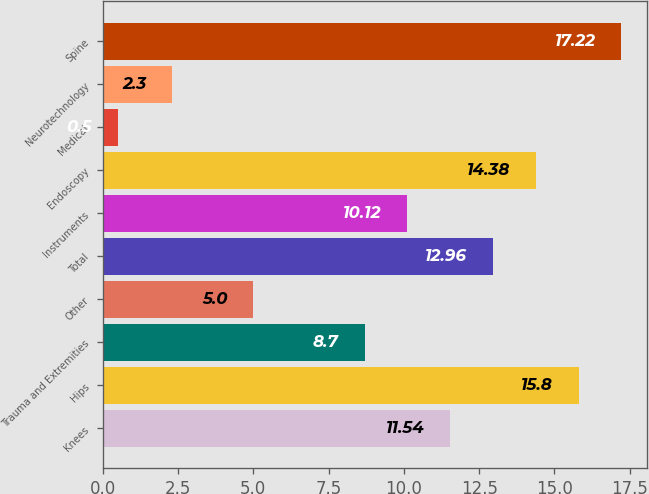Convert chart to OTSL. <chart><loc_0><loc_0><loc_500><loc_500><bar_chart><fcel>Knees<fcel>Hips<fcel>Trauma and Extremities<fcel>Other<fcel>Total<fcel>Instruments<fcel>Endoscopy<fcel>Medical<fcel>Neurotechnology<fcel>Spine<nl><fcel>11.54<fcel>15.8<fcel>8.7<fcel>5<fcel>12.96<fcel>10.12<fcel>14.38<fcel>0.5<fcel>2.3<fcel>17.22<nl></chart> 